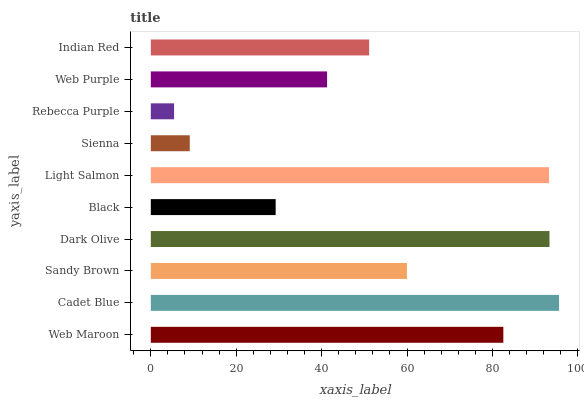Is Rebecca Purple the minimum?
Answer yes or no. Yes. Is Cadet Blue the maximum?
Answer yes or no. Yes. Is Sandy Brown the minimum?
Answer yes or no. No. Is Sandy Brown the maximum?
Answer yes or no. No. Is Cadet Blue greater than Sandy Brown?
Answer yes or no. Yes. Is Sandy Brown less than Cadet Blue?
Answer yes or no. Yes. Is Sandy Brown greater than Cadet Blue?
Answer yes or no. No. Is Cadet Blue less than Sandy Brown?
Answer yes or no. No. Is Sandy Brown the high median?
Answer yes or no. Yes. Is Indian Red the low median?
Answer yes or no. Yes. Is Cadet Blue the high median?
Answer yes or no. No. Is Cadet Blue the low median?
Answer yes or no. No. 